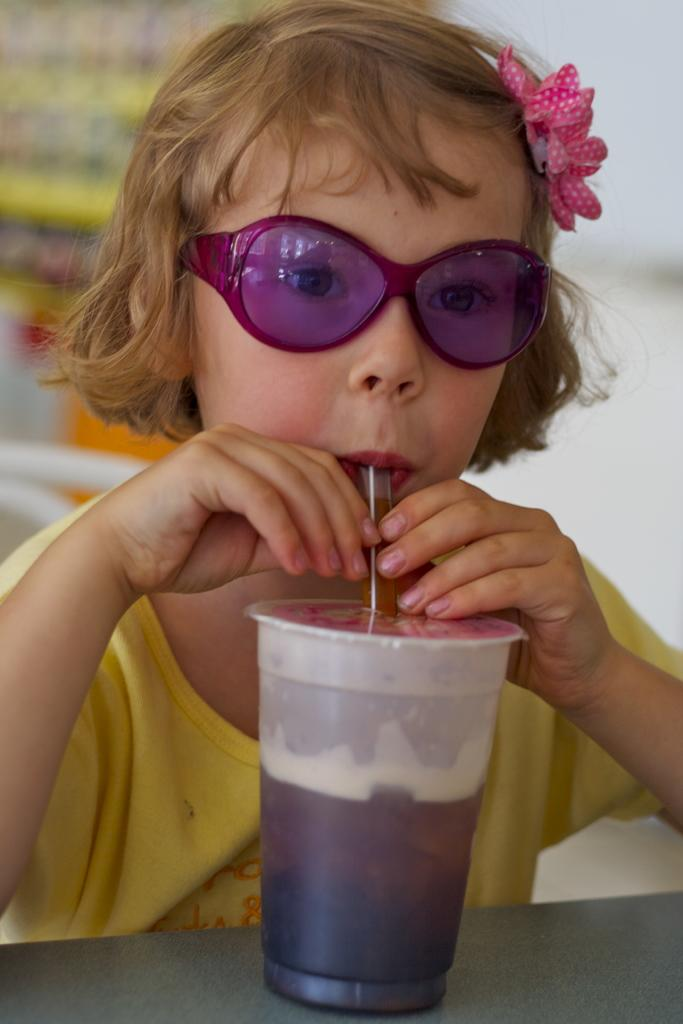Who is the main subject in the image? There is a girl in the image. What is the girl doing in the image? The girl is drinking through a straw in the image. What is the girl drinking from? The straw is in a juice bottle. What accessory is the girl wearing? The girl is wearing pink-colored goggles. What type of ice is the girl using to cool down in the image? There is no ice present in the image; the girl is drinking from a juice bottle using a straw. 